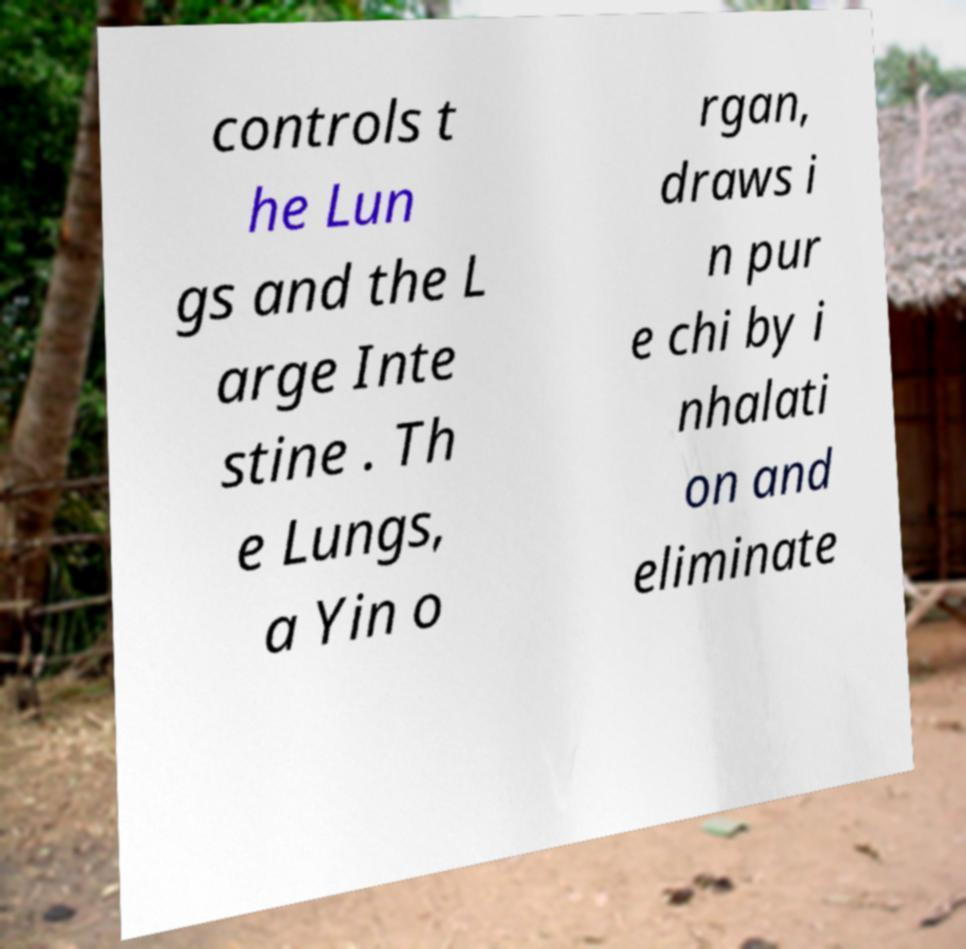I need the written content from this picture converted into text. Can you do that? controls t he Lun gs and the L arge Inte stine . Th e Lungs, a Yin o rgan, draws i n pur e chi by i nhalati on and eliminate 